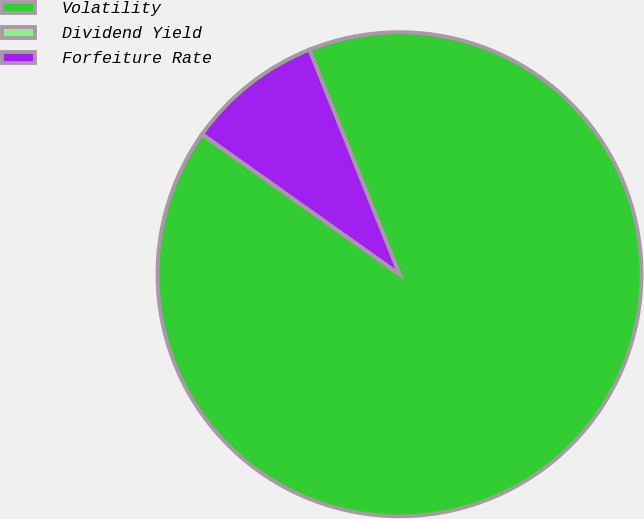Convert chart. <chart><loc_0><loc_0><loc_500><loc_500><pie_chart><fcel>Volatility<fcel>Dividend Yield<fcel>Forfeiture Rate<nl><fcel>90.89%<fcel>0.01%<fcel>9.1%<nl></chart> 